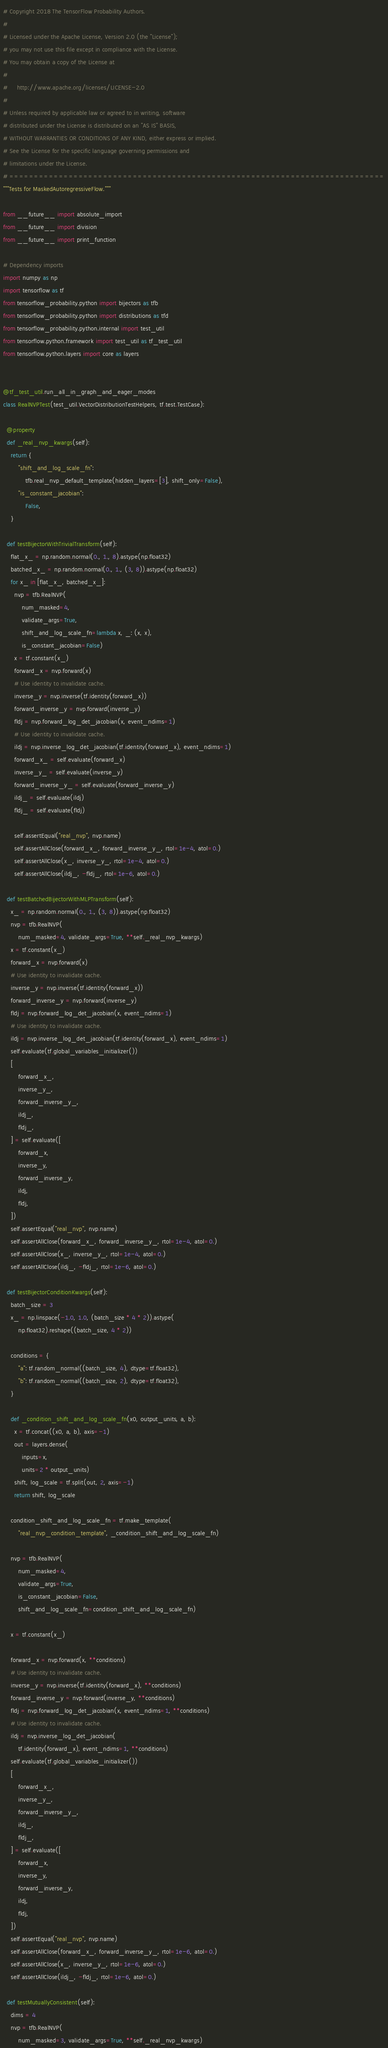Convert code to text. <code><loc_0><loc_0><loc_500><loc_500><_Python_># Copyright 2018 The TensorFlow Probability Authors.
#
# Licensed under the Apache License, Version 2.0 (the "License");
# you may not use this file except in compliance with the License.
# You may obtain a copy of the License at
#
#     http://www.apache.org/licenses/LICENSE-2.0
#
# Unless required by applicable law or agreed to in writing, software
# distributed under the License is distributed on an "AS IS" BASIS,
# WITHOUT WARRANTIES OR CONDITIONS OF ANY KIND, either express or implied.
# See the License for the specific language governing permissions and
# limitations under the License.
# ============================================================================
"""Tests for MaskedAutoregressiveFlow."""

from __future__ import absolute_import
from __future__ import division
from __future__ import print_function

# Dependency imports
import numpy as np
import tensorflow as tf
from tensorflow_probability.python import bijectors as tfb
from tensorflow_probability.python import distributions as tfd
from tensorflow_probability.python.internal import test_util
from tensorflow.python.framework import test_util as tf_test_util
from tensorflow.python.layers import core as layers


@tf_test_util.run_all_in_graph_and_eager_modes
class RealNVPTest(test_util.VectorDistributionTestHelpers, tf.test.TestCase):

  @property
  def _real_nvp_kwargs(self):
    return {
        "shift_and_log_scale_fn":
            tfb.real_nvp_default_template(hidden_layers=[3], shift_only=False),
        "is_constant_jacobian":
            False,
    }

  def testBijectorWithTrivialTransform(self):
    flat_x_ = np.random.normal(0., 1., 8).astype(np.float32)
    batched_x_ = np.random.normal(0., 1., (3, 8)).astype(np.float32)
    for x_ in [flat_x_, batched_x_]:
      nvp = tfb.RealNVP(
          num_masked=4,
          validate_args=True,
          shift_and_log_scale_fn=lambda x, _: (x, x),
          is_constant_jacobian=False)
      x = tf.constant(x_)
      forward_x = nvp.forward(x)
      # Use identity to invalidate cache.
      inverse_y = nvp.inverse(tf.identity(forward_x))
      forward_inverse_y = nvp.forward(inverse_y)
      fldj = nvp.forward_log_det_jacobian(x, event_ndims=1)
      # Use identity to invalidate cache.
      ildj = nvp.inverse_log_det_jacobian(tf.identity(forward_x), event_ndims=1)
      forward_x_ = self.evaluate(forward_x)
      inverse_y_ = self.evaluate(inverse_y)
      forward_inverse_y_ = self.evaluate(forward_inverse_y)
      ildj_ = self.evaluate(ildj)
      fldj_ = self.evaluate(fldj)

      self.assertEqual("real_nvp", nvp.name)
      self.assertAllClose(forward_x_, forward_inverse_y_, rtol=1e-4, atol=0.)
      self.assertAllClose(x_, inverse_y_, rtol=1e-4, atol=0.)
      self.assertAllClose(ildj_, -fldj_, rtol=1e-6, atol=0.)

  def testBatchedBijectorWithMLPTransform(self):
    x_ = np.random.normal(0., 1., (3, 8)).astype(np.float32)
    nvp = tfb.RealNVP(
        num_masked=4, validate_args=True, **self._real_nvp_kwargs)
    x = tf.constant(x_)
    forward_x = nvp.forward(x)
    # Use identity to invalidate cache.
    inverse_y = nvp.inverse(tf.identity(forward_x))
    forward_inverse_y = nvp.forward(inverse_y)
    fldj = nvp.forward_log_det_jacobian(x, event_ndims=1)
    # Use identity to invalidate cache.
    ildj = nvp.inverse_log_det_jacobian(tf.identity(forward_x), event_ndims=1)
    self.evaluate(tf.global_variables_initializer())
    [
        forward_x_,
        inverse_y_,
        forward_inverse_y_,
        ildj_,
        fldj_,
    ] = self.evaluate([
        forward_x,
        inverse_y,
        forward_inverse_y,
        ildj,
        fldj,
    ])
    self.assertEqual("real_nvp", nvp.name)
    self.assertAllClose(forward_x_, forward_inverse_y_, rtol=1e-4, atol=0.)
    self.assertAllClose(x_, inverse_y_, rtol=1e-4, atol=0.)
    self.assertAllClose(ildj_, -fldj_, rtol=1e-6, atol=0.)

  def testBijectorConditionKwargs(self):
    batch_size = 3
    x_ = np.linspace(-1.0, 1.0, (batch_size * 4 * 2)).astype(
        np.float32).reshape((batch_size, 4 * 2))

    conditions = {
        "a": tf.random_normal((batch_size, 4), dtype=tf.float32),
        "b": tf.random_normal((batch_size, 2), dtype=tf.float32),
    }

    def _condition_shift_and_log_scale_fn(x0, output_units, a, b):
      x = tf.concat((x0, a, b), axis=-1)
      out = layers.dense(
          inputs=x,
          units=2 * output_units)
      shift, log_scale = tf.split(out, 2, axis=-1)
      return shift, log_scale

    condition_shift_and_log_scale_fn = tf.make_template(
        "real_nvp_condition_template", _condition_shift_and_log_scale_fn)

    nvp = tfb.RealNVP(
        num_masked=4,
        validate_args=True,
        is_constant_jacobian=False,
        shift_and_log_scale_fn=condition_shift_and_log_scale_fn)

    x = tf.constant(x_)

    forward_x = nvp.forward(x, **conditions)
    # Use identity to invalidate cache.
    inverse_y = nvp.inverse(tf.identity(forward_x), **conditions)
    forward_inverse_y = nvp.forward(inverse_y, **conditions)
    fldj = nvp.forward_log_det_jacobian(x, event_ndims=1, **conditions)
    # Use identity to invalidate cache.
    ildj = nvp.inverse_log_det_jacobian(
        tf.identity(forward_x), event_ndims=1, **conditions)
    self.evaluate(tf.global_variables_initializer())
    [
        forward_x_,
        inverse_y_,
        forward_inverse_y_,
        ildj_,
        fldj_,
    ] = self.evaluate([
        forward_x,
        inverse_y,
        forward_inverse_y,
        ildj,
        fldj,
    ])
    self.assertEqual("real_nvp", nvp.name)
    self.assertAllClose(forward_x_, forward_inverse_y_, rtol=1e-6, atol=0.)
    self.assertAllClose(x_, inverse_y_, rtol=1e-6, atol=0.)
    self.assertAllClose(ildj_, -fldj_, rtol=1e-6, atol=0.)

  def testMutuallyConsistent(self):
    dims = 4
    nvp = tfb.RealNVP(
        num_masked=3, validate_args=True, **self._real_nvp_kwargs)</code> 